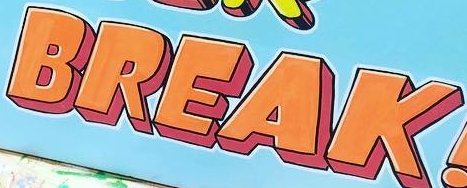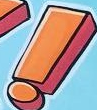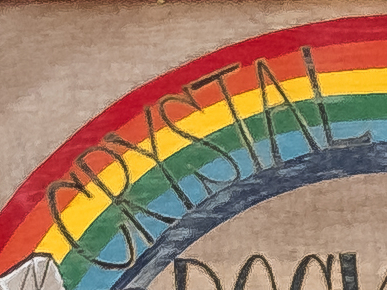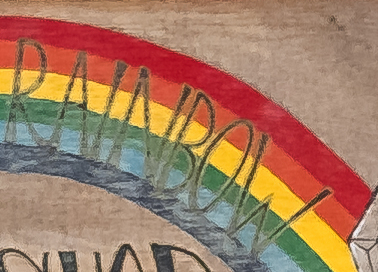Read the text content from these images in order, separated by a semicolon. BREAK; !; CRYSTAL; RNNBOW 